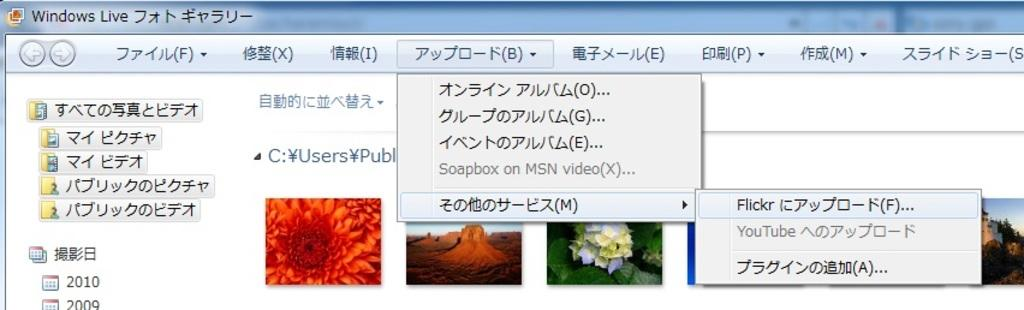What type of image is shown in the screenshot? The image is a screenshot of a desktop screen. What can be seen in the middle of the screen? There are wallpapers in the middle of the screen. Is there any text visible on the desktop screen? Yes, there is text above the wallpapers. What type of hat is the yoke wearing in the image? There is no yoke or hat present in the image. 